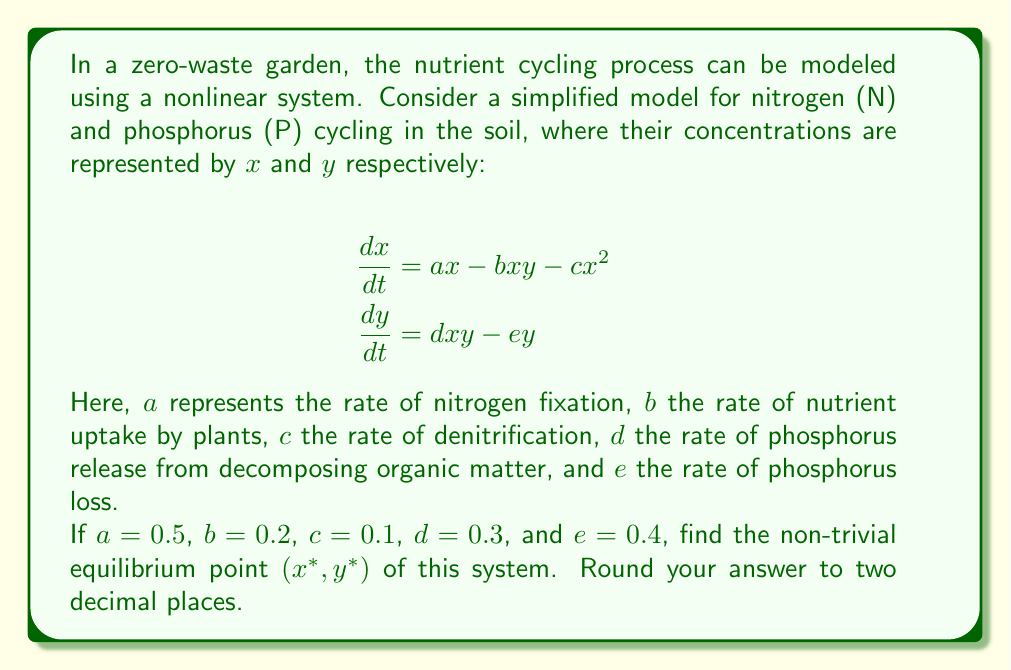Can you answer this question? To find the equilibrium point, we need to set both equations equal to zero and solve for $x$ and $y$:

1) Set $\frac{dx}{dt} = 0$ and $\frac{dy}{dt} = 0$:

   $0 = ax - bxy - cx^2$
   $0 = dxy - ey$

2) From the second equation:
   $dxy = ey$
   $x = \frac{e}{d}$ (assuming $y \neq 0$)

3) Substitute this into the first equation:
   $0 = a(\frac{e}{d}) - b(\frac{e}{d})y - c(\frac{e}{d})^2$

4) Simplify:
   $0 = \frac{ae}{d} - \frac{be}{d}y - \frac{ce^2}{d^2}$

5) Solve for $y$:
   $\frac{be}{d}y = \frac{ae}{d} - \frac{ce^2}{d^2}$
   $y = \frac{ad - ce}{bd}$

6) Now we have $x^*$ and $y^*$:
   $x^* = \frac{e}{d} = \frac{0.4}{0.3} = 1.33$
   $y^* = \frac{ad - ce}{bd} = \frac{0.5 \cdot 0.3 - 0.1 \cdot 0.4}{0.2 \cdot 0.3} = 2.33$

7) Rounding to two decimal places:
   $x^* = 1.33$
   $y^* = 2.33$

Therefore, the non-trivial equilibrium point is (1.33, 2.33).
Answer: (1.33, 2.33) 